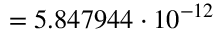Convert formula to latex. <formula><loc_0><loc_0><loc_500><loc_500>= 5 . 8 4 7 9 4 4 \cdot 1 0 ^ { - 1 2 }</formula> 